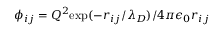<formula> <loc_0><loc_0><loc_500><loc_500>\phi _ { i j } = Q ^ { 2 } e x p ( - r _ { i j } / \lambda _ { D } ) / 4 \pi \epsilon _ { 0 } r _ { i j }</formula> 